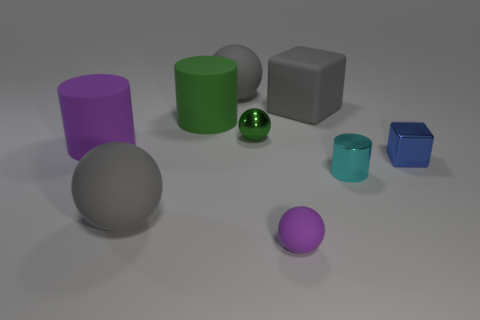What shape is the tiny thing that is to the left of the blue cube and to the right of the gray rubber block? The tiny item situated to the left of the blue cube and to the right of the gray rubber block is a green sphere. It appears to be a small, shiny marble or similar spherical object. 